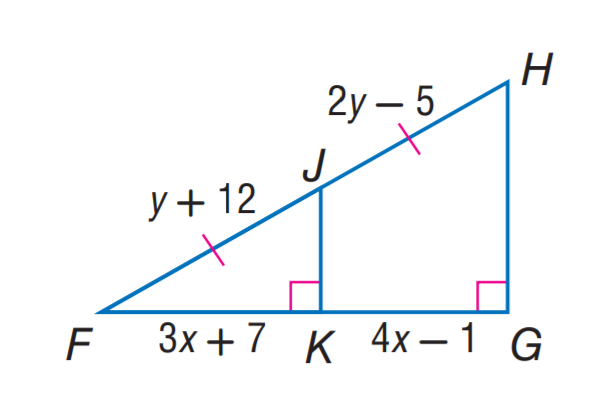Question: Find y.
Choices:
A. 7
B. 8
C. 12
D. 17
Answer with the letter. Answer: D 